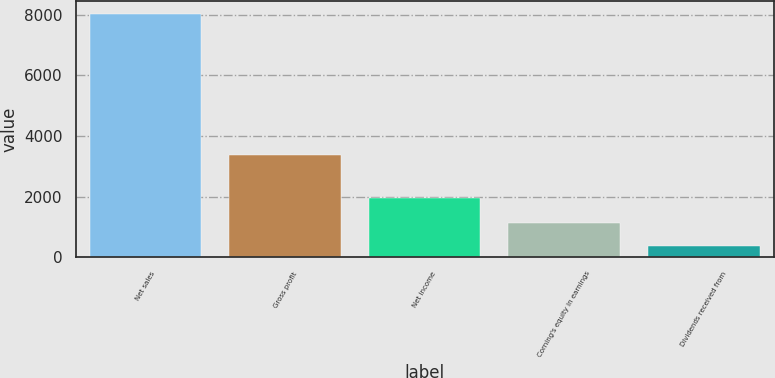<chart> <loc_0><loc_0><loc_500><loc_500><bar_chart><fcel>Net sales<fcel>Gross profit<fcel>Net income<fcel>Corning's equity in earnings<fcel>Dividends received from<nl><fcel>8039<fcel>3368<fcel>1968<fcel>1130.6<fcel>363<nl></chart> 